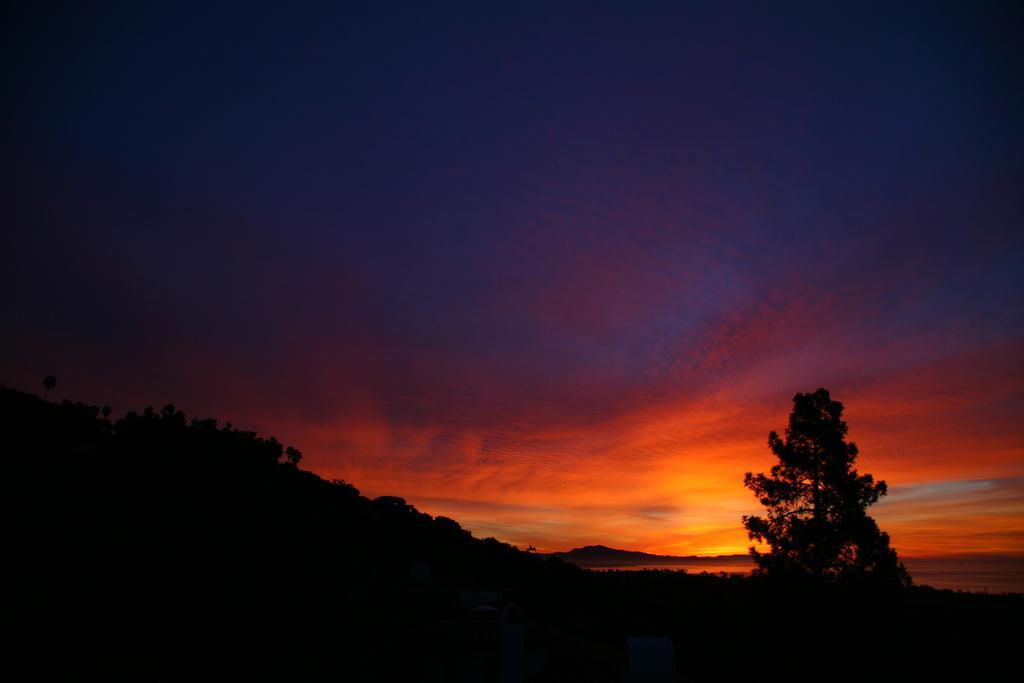Can you describe this image briefly? In this image we can see trees, hill and sky. And image is looking dark. 